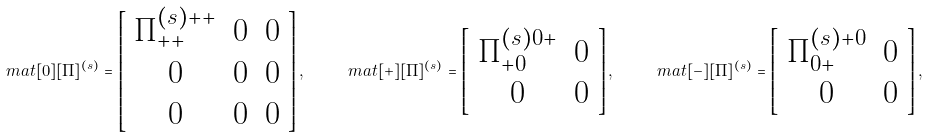<formula> <loc_0><loc_0><loc_500><loc_500>\ m a t [ 0 ] [ \Pi ] ^ { ( s ) } = \left [ \begin{array} { c c c } \Pi ^ { ( s ) + + } _ { + + } & 0 & 0 \\ 0 & 0 & 0 \\ 0 & 0 & 0 \end{array} \right ] , \quad \ m a t [ + ] [ \Pi ] ^ { ( s ) } = \left [ \begin{array} { c c } \Pi ^ { ( s ) 0 + } _ { + 0 } & 0 \\ 0 & 0 \end{array} \right ] , \quad \ m a t [ - ] [ \Pi ] ^ { ( s ) } = \left [ \begin{array} { c c } \Pi ^ { ( s ) + 0 } _ { 0 + } & 0 \\ 0 & 0 \end{array} \right ] ,</formula> 